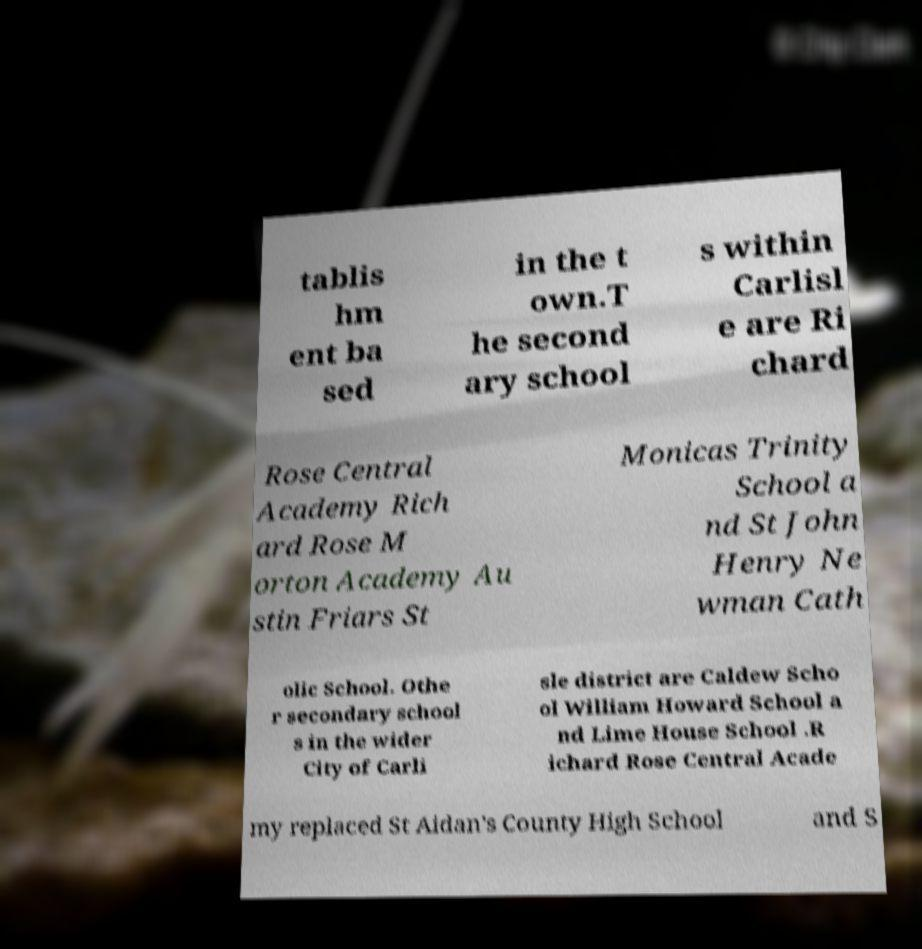Can you read and provide the text displayed in the image?This photo seems to have some interesting text. Can you extract and type it out for me? tablis hm ent ba sed in the t own.T he second ary school s within Carlisl e are Ri chard Rose Central Academy Rich ard Rose M orton Academy Au stin Friars St Monicas Trinity School a nd St John Henry Ne wman Cath olic School. Othe r secondary school s in the wider City of Carli sle district are Caldew Scho ol William Howard School a nd Lime House School .R ichard Rose Central Acade my replaced St Aidan's County High School and S 